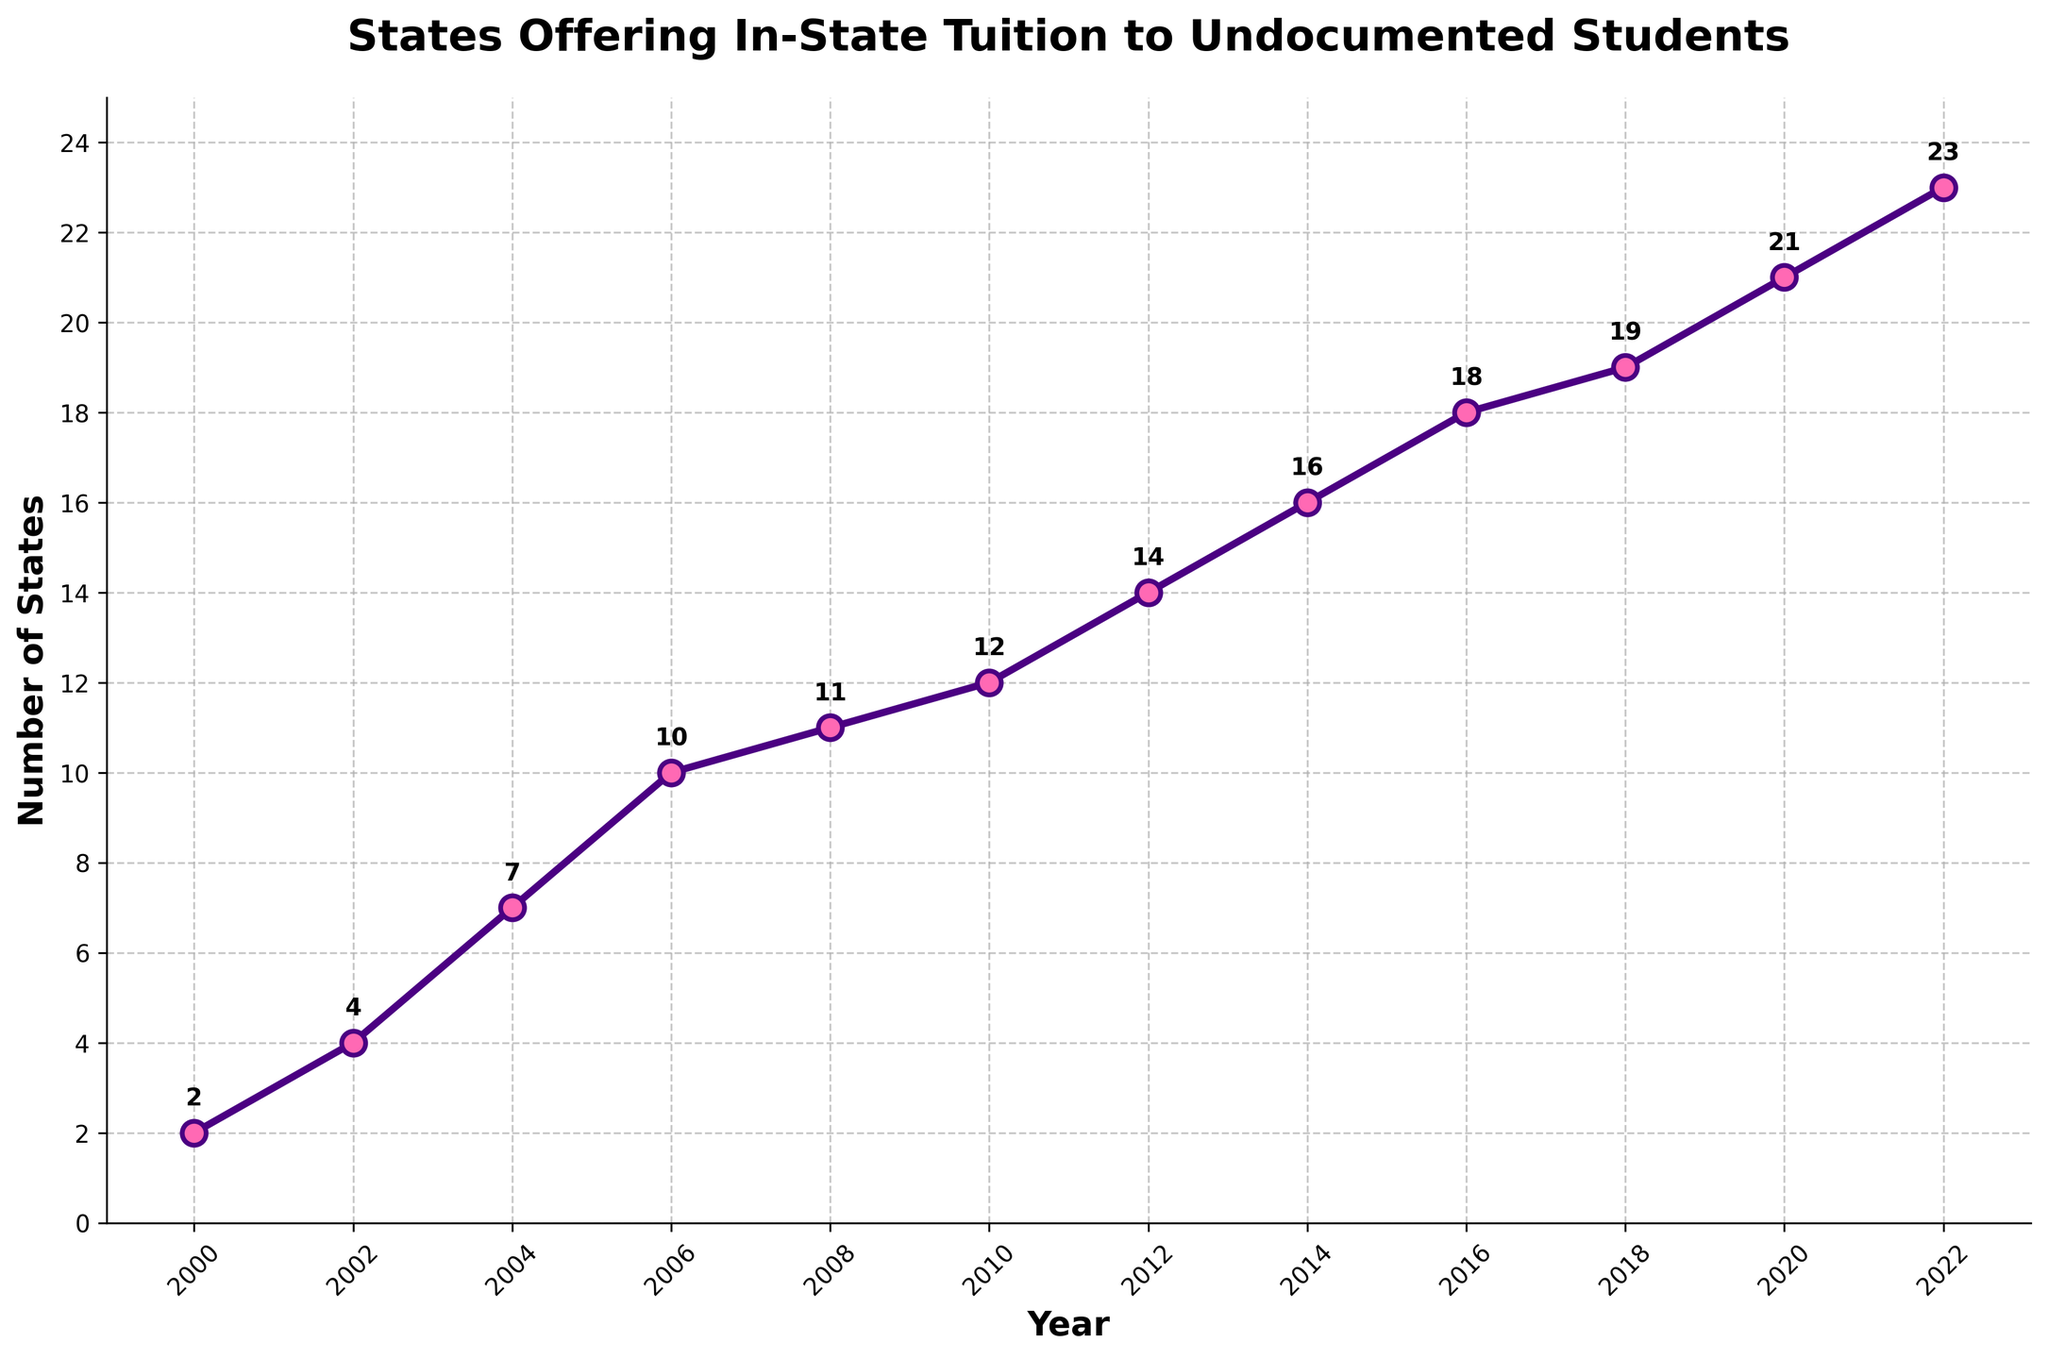What is the total increase in the number of states offering in-state tuition to undocumented students from 2000 to 2022? The number of states in 2000 is 2 and in 2022 is 23. The total increase is 23 - 2 = 21.
Answer: 21 In which year did the number of states first reach double digits? The data shows that the number of states first reached 10 in 2006.
Answer: 2006 Calculate the average increase in the number of states offering in-state tuition to undocumented students for each two-year interval from 2000 to 2020. From 2000 to 2020, there are 10 intervals. The state counts for these years are: 2, 4, 7, 10, 11, 12, 14, 16, 18, 19, 21. The increases are: 2, 3, 3, 1, 1, 2, 2, 2, 1, 2. Sum is 19. Divide by 10 intervals: 19/10 = 1.9.
Answer: 1.9 Which period had the largest single increase in the number of states? Check each two-year interval for the largest increase. The largest increase is from 2002 to 2004 (an increase of 3 states).
Answer: 2002 to 2004 How many states were offering in-state tuition to undocumented students by 2010? The number of states in 2010 was 12, according to the data.
Answer: 12 During which two consecutive years did the number of states remain constant? The data shows no change between 2008 and 2010.
Answer: 2008 to 2010 How many times did the number of states increase by exactly 2 in a two-year interval? The increases by exactly 2 occur from 2012 to 2014, 2014 to 2016, 2016 to 2018, and 2020 to 2022. Count these occurrences: 4 times.
Answer: 4 By what percentage did the number of states offering in-state tuition increase from 2000 to 2020? Increase from 2 to 21 is 21 - 2 = 19. The percentage increase is (19/2) * 100 = 950%.
Answer: 950% Which year had exactly half the number of states as there were in 2022? In 2022, there are 23 states. Half is 23 / 2 = 11.5. The nearest whole number is 11, and that was in 2008.
Answer: 2008 